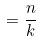Convert formula to latex. <formula><loc_0><loc_0><loc_500><loc_500>= \frac { n } { k }</formula> 